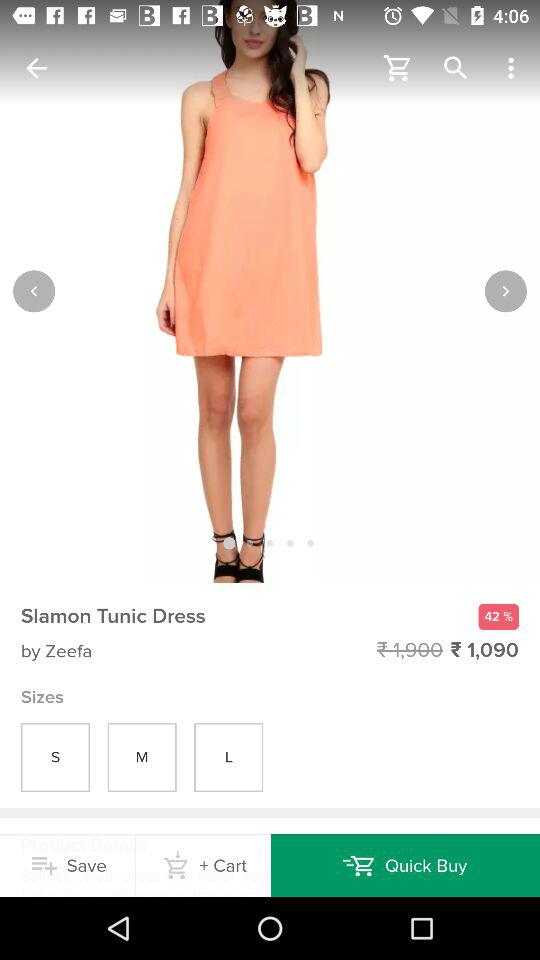What's the dress name? The dress name is "Slamon Tunic Dress". 